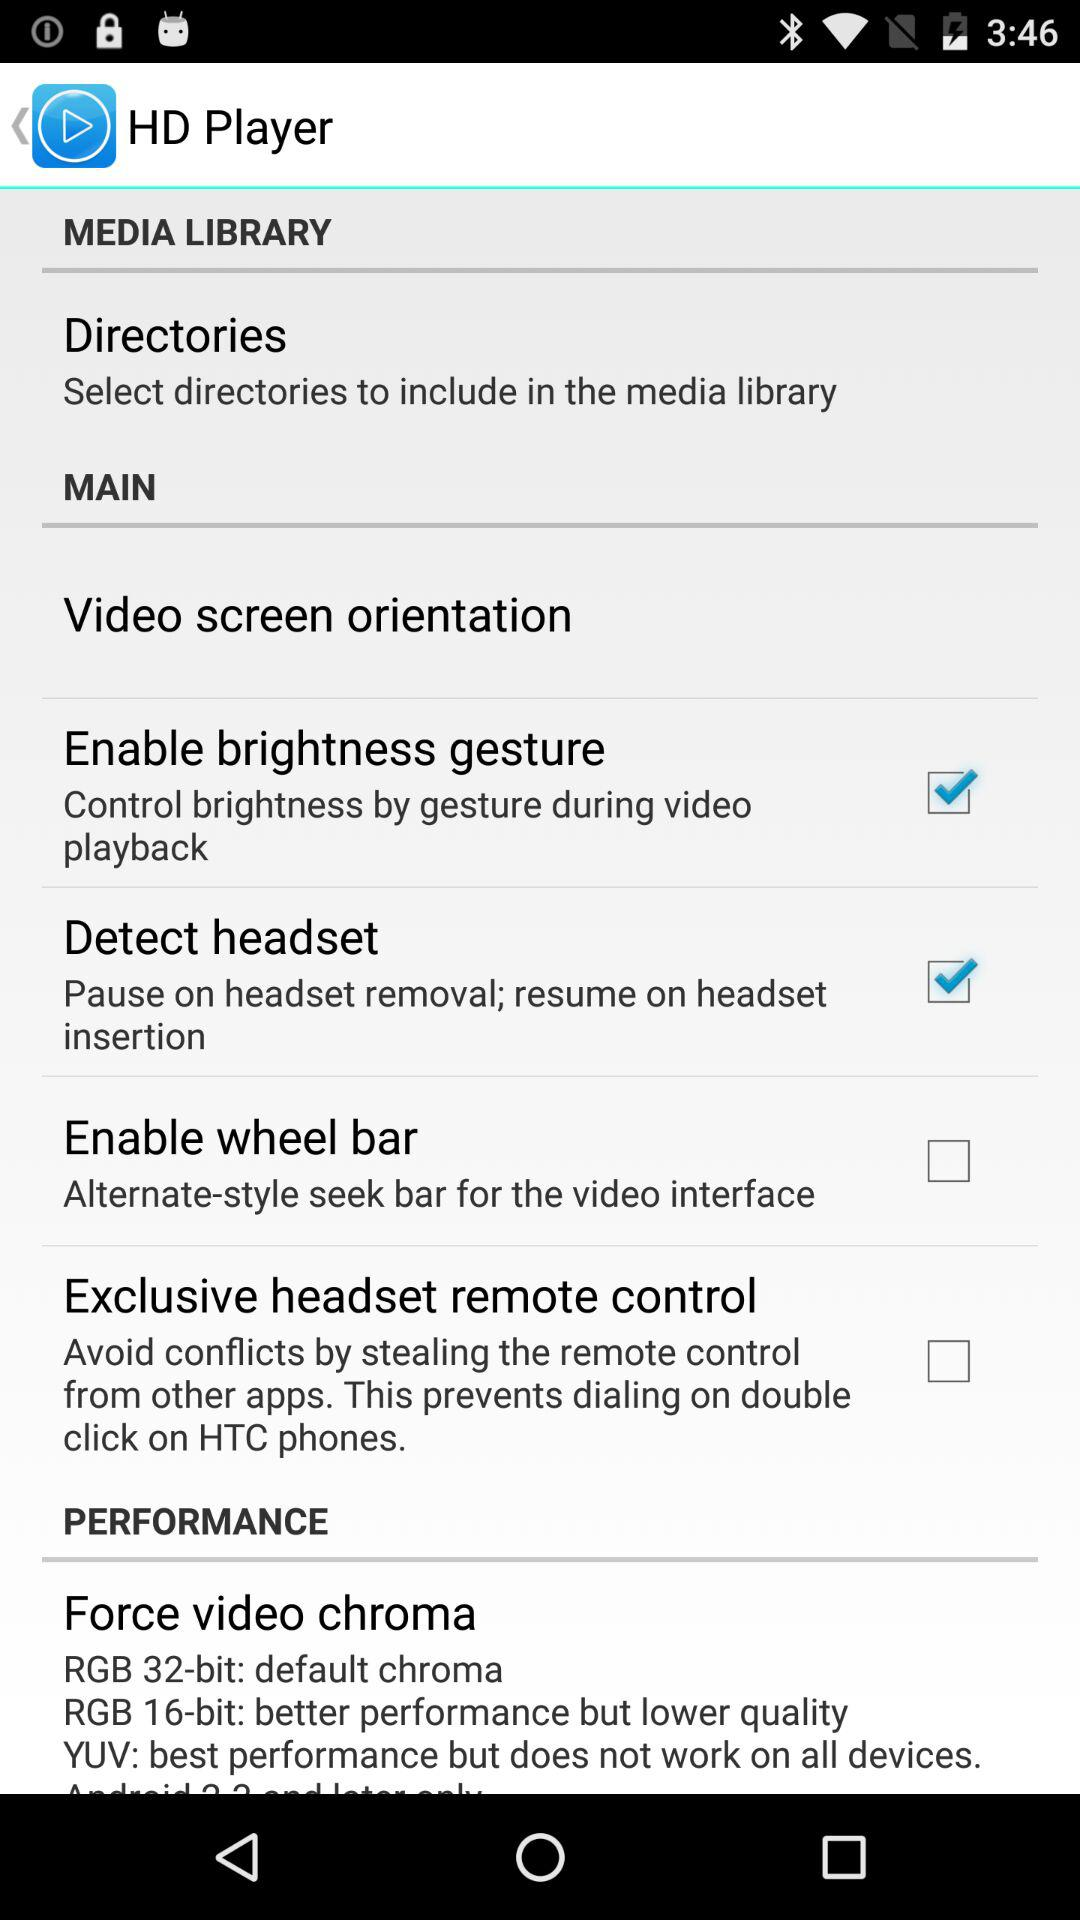What is the bit size for default chroma? The bit size for default chroma is 32. 